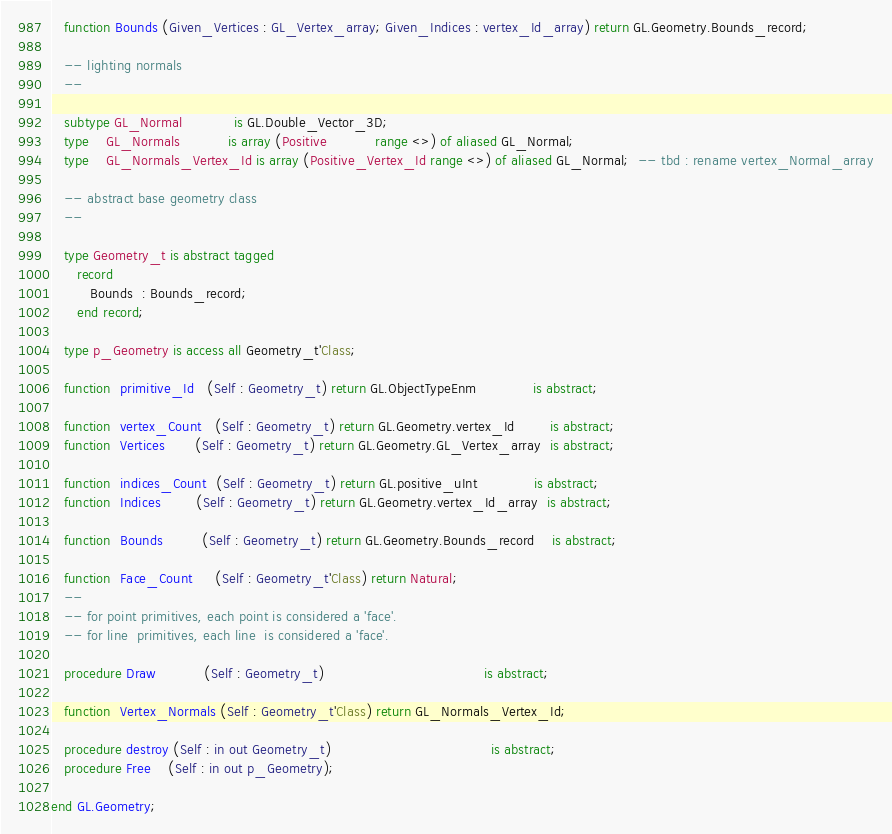<code> <loc_0><loc_0><loc_500><loc_500><_Ada_>
   function Bounds (Given_Vertices : GL_Vertex_array; Given_Indices : vertex_Id_array) return GL.Geometry.Bounds_record;

   -- lighting normals
   --

   subtype GL_Normal            is GL.Double_Vector_3D;
   type    GL_Normals           is array (Positive           range <>) of aliased GL_Normal;
   type    GL_Normals_Vertex_Id is array (Positive_Vertex_Id range <>) of aliased GL_Normal;  -- tbd : rename vertex_Normal_array

   -- abstract base geometry class
   --

   type Geometry_t is abstract tagged
      record
         Bounds  : Bounds_record;
      end record;

   type p_Geometry is access all Geometry_t'Class;

   function  primitive_Id   (Self : Geometry_t) return GL.ObjectTypeEnm             is abstract;

   function  vertex_Count   (Self : Geometry_t) return GL.Geometry.vertex_Id        is abstract;
   function  Vertices       (Self : Geometry_t) return GL.Geometry.GL_Vertex_array  is abstract;

   function  indices_Count  (Self : Geometry_t) return GL.positive_uInt             is abstract;
   function  Indices        (Self : Geometry_t) return GL.Geometry.vertex_Id_array  is abstract;

   function  Bounds         (Self : Geometry_t) return GL.Geometry.Bounds_record    is abstract;

   function  Face_Count     (Self : Geometry_t'Class) return Natural;
   --
   -- for point primitives, each point is considered a 'face'.
   -- for line  primitives, each line  is considered a 'face'.

   procedure Draw           (Self : Geometry_t)                                     is abstract;

   function  Vertex_Normals (Self : Geometry_t'Class) return GL_Normals_Vertex_Id;

   procedure destroy (Self : in out Geometry_t)                                     is abstract;
   procedure Free    (Self : in out p_Geometry);

end GL.Geometry;
</code> 